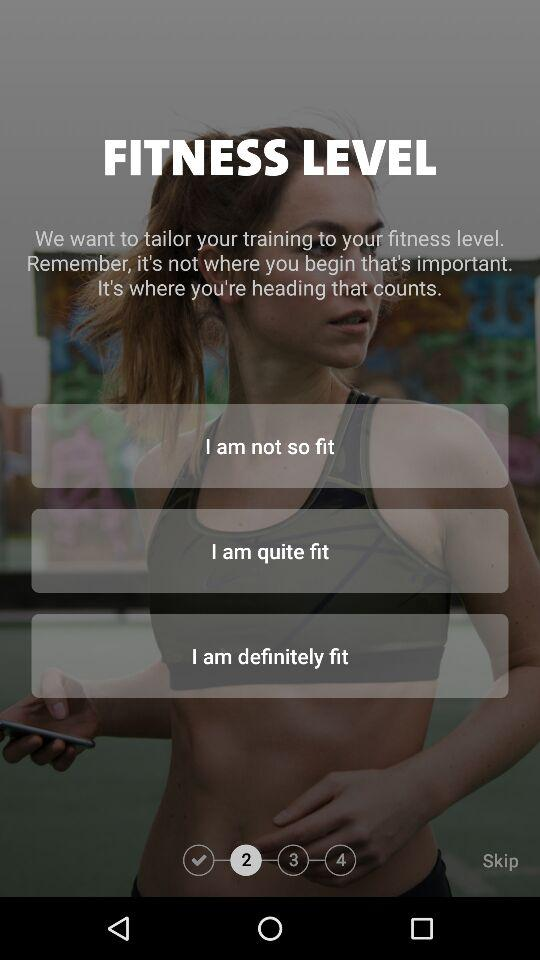What is the total number of fitness levels?
When the provided information is insufficient, respond with <no answer>. <no answer> 